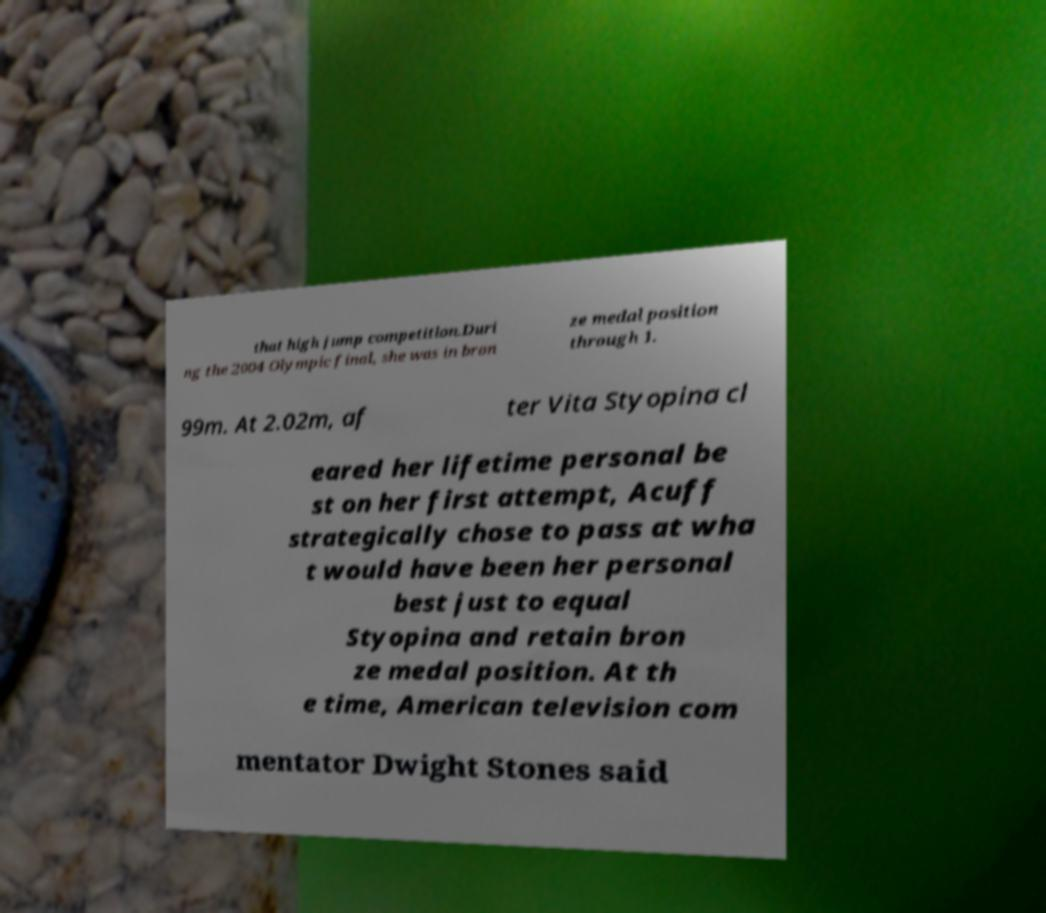For documentation purposes, I need the text within this image transcribed. Could you provide that? that high jump competition.Duri ng the 2004 Olympic final, she was in bron ze medal position through 1. 99m. At 2.02m, af ter Vita Styopina cl eared her lifetime personal be st on her first attempt, Acuff strategically chose to pass at wha t would have been her personal best just to equal Styopina and retain bron ze medal position. At th e time, American television com mentator Dwight Stones said 